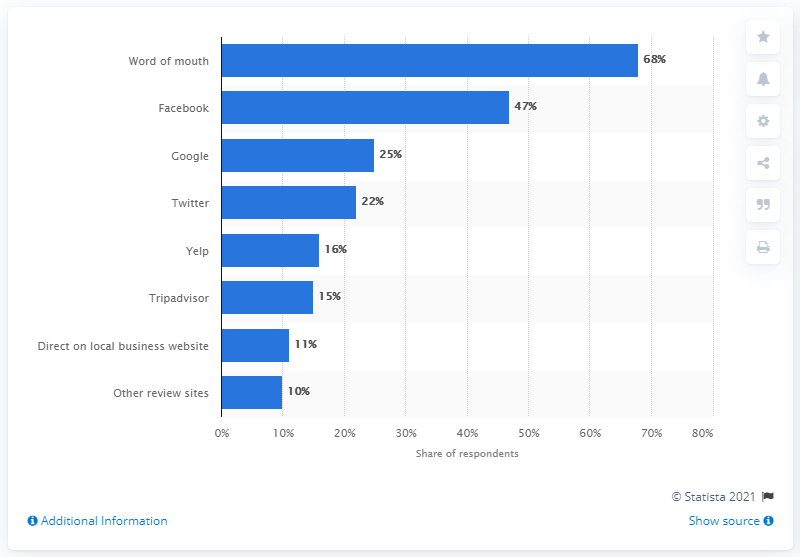Draw attention to some important aspects in this diagram. According to the survey, 47% of respondents reported using Facebook to recommend local businesses. 